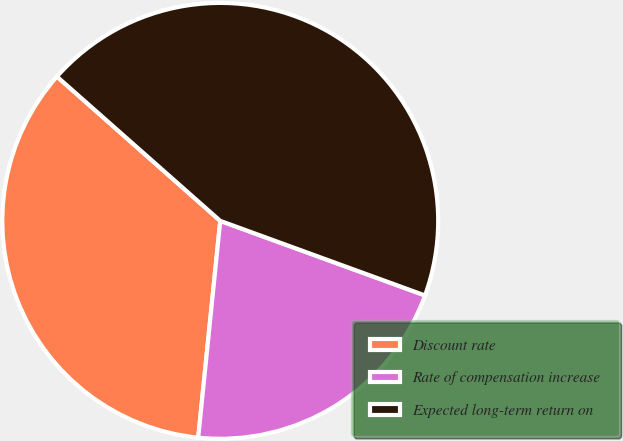Convert chart to OTSL. <chart><loc_0><loc_0><loc_500><loc_500><pie_chart><fcel>Discount rate<fcel>Rate of compensation increase<fcel>Expected long-term return on<nl><fcel>34.9%<fcel>21.05%<fcel>44.04%<nl></chart> 